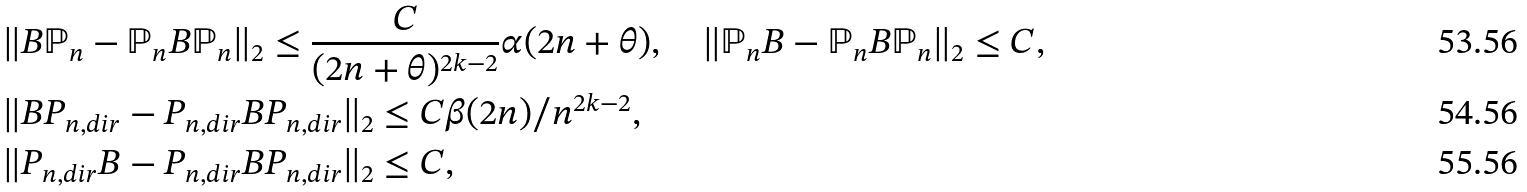Convert formula to latex. <formula><loc_0><loc_0><loc_500><loc_500>& \| B \mathbb { P } _ { n } - \mathbb { P } _ { n } B \mathbb { P } _ { n } \| _ { 2 } \leq \frac { C } { ( 2 n + \theta ) ^ { 2 k - 2 } } \alpha ( 2 n + \theta ) , \quad \| \mathbb { P } _ { n } B - \mathbb { P } _ { n } B \mathbb { P } _ { n } \| _ { 2 } \leq C , \\ & \| B P _ { n , d i r } - P _ { n , d i r } B P _ { n , d i r } \| _ { 2 } \leq C \beta ( 2 n ) / n ^ { 2 k - 2 } , \\ & \| P _ { n , d i r } B - P _ { n , d i r } B P _ { n , d i r } \| _ { 2 } \leq C ,</formula> 